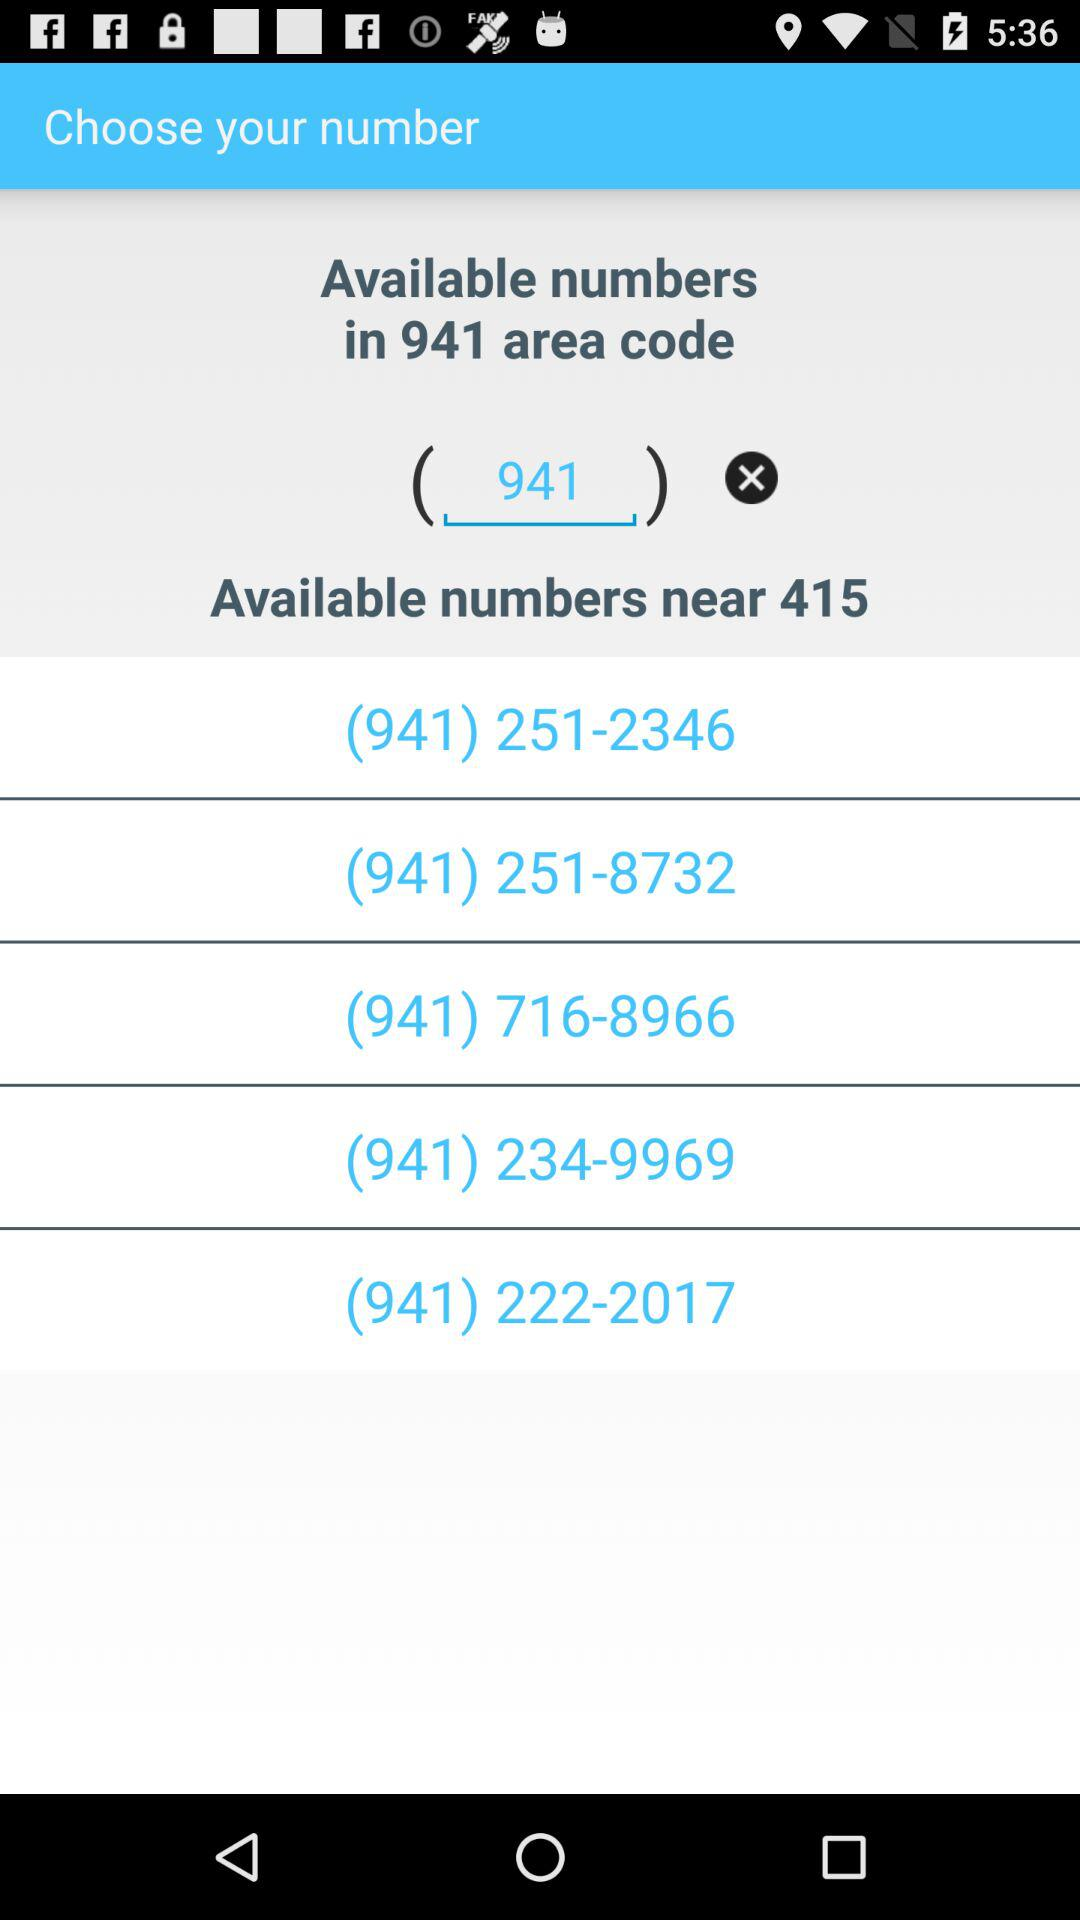How many numbers are in the search results?
Answer the question using a single word or phrase. 5 